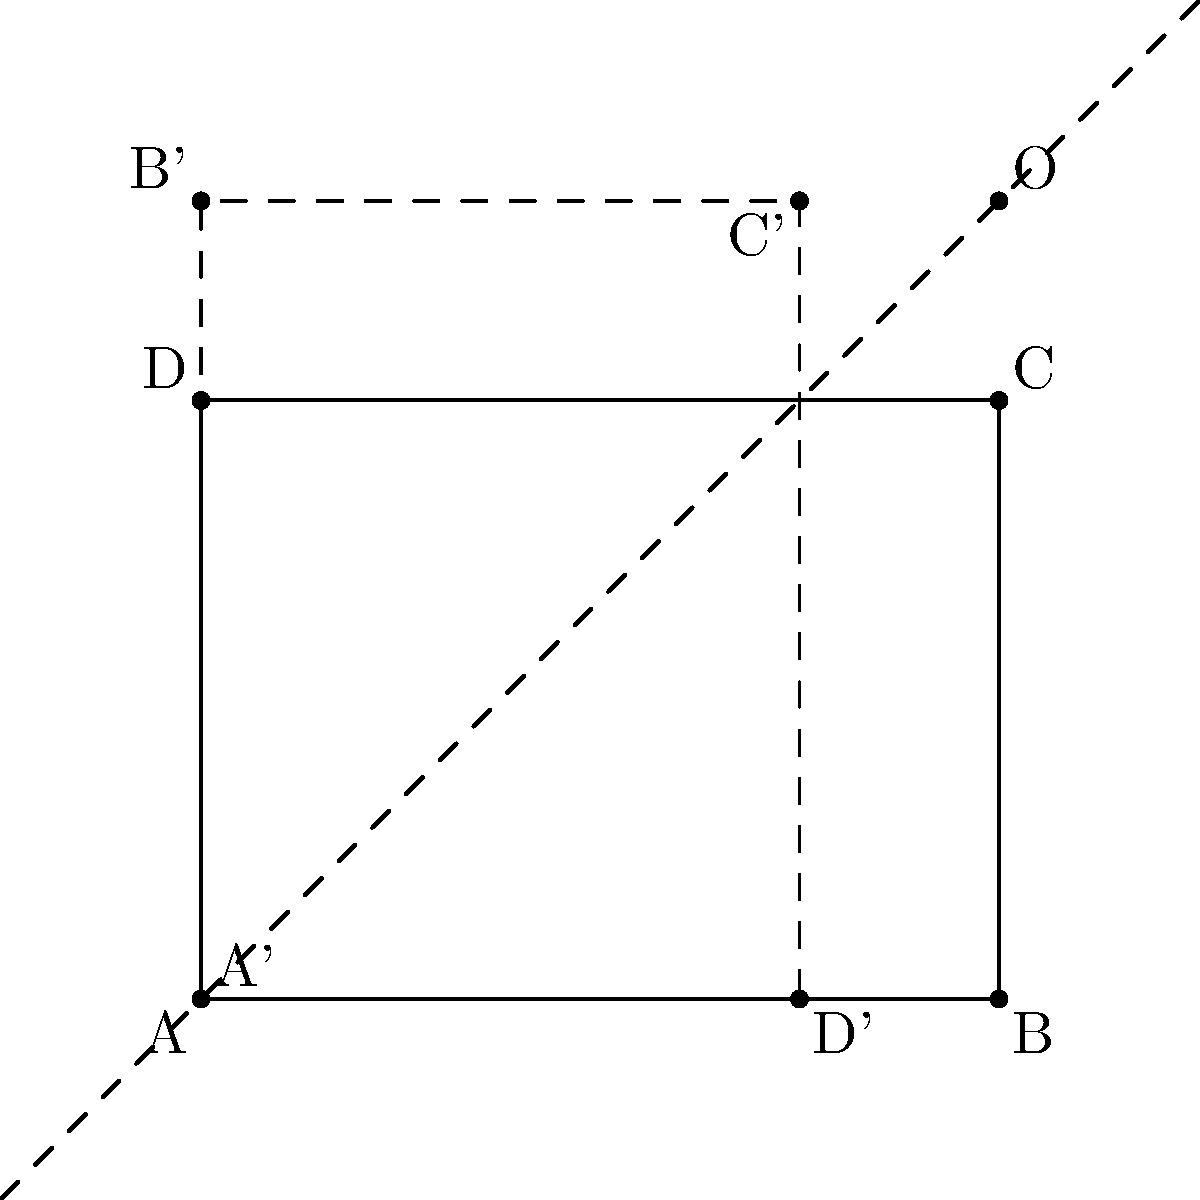In a software application designed to improve mental health outcomes, you're developing a feature that uses geometric transformations to represent emotional states. A rectangle ABCD represents the initial emotional state, with coordinates A(0,0), B(4,0), C(4,3), and D(0,3). The rectangle is reflected across the line y=x to represent a shift in emotional perspective. What are the coordinates of point C' after the reflection? To solve this problem, we'll follow these steps:

1) The line of reflection is y=x, which passes through the origin (0,0) and the point (1,1).

2) To reflect a point (x,y) across the line y=x, we swap its x and y coordinates. So (x,y) becomes (y,x).

3) The original coordinates of point C are (4,3).

4) After reflection:
   x' = 3 (original y)
   y' = 4 (original x)

5) Therefore, the coordinates of C' after reflection are (3,4).

This transformation can be interpreted in the context of mental health as a shift in perspective, where the dimensions of the emotional state (represented by the coordinates) are interchanged, potentially indicating a new way of viewing one's emotional condition.
Answer: (3,4) 